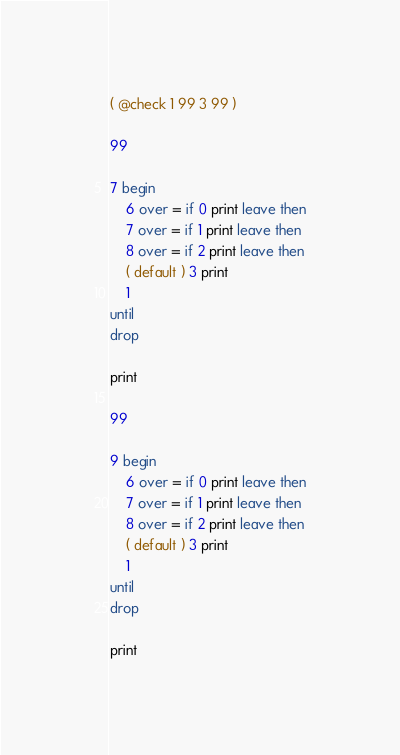<code> <loc_0><loc_0><loc_500><loc_500><_Forth_>( @check 1 99 3 99 )

99

7 begin
    6 over = if 0 print leave then
    7 over = if 1 print leave then
    8 over = if 2 print leave then
    ( default ) 3 print
    1
until
drop

print

99

9 begin
    6 over = if 0 print leave then
    7 over = if 1 print leave then
    8 over = if 2 print leave then
    ( default ) 3 print
    1
until
drop

print
</code> 